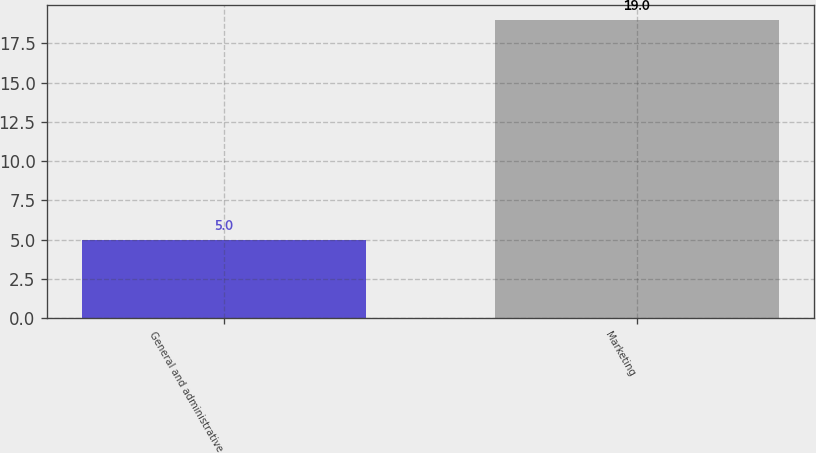Convert chart to OTSL. <chart><loc_0><loc_0><loc_500><loc_500><bar_chart><fcel>General and administrative<fcel>Marketing<nl><fcel>5<fcel>19<nl></chart> 